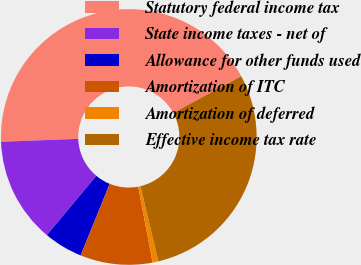Convert chart to OTSL. <chart><loc_0><loc_0><loc_500><loc_500><pie_chart><fcel>Statutory federal income tax<fcel>State income taxes - net of<fcel>Allowance for other funds used<fcel>Amortization of ITC<fcel>Amortization of deferred<fcel>Effective income tax rate<nl><fcel>42.71%<fcel>13.33%<fcel>4.93%<fcel>9.13%<fcel>0.73%<fcel>29.17%<nl></chart> 